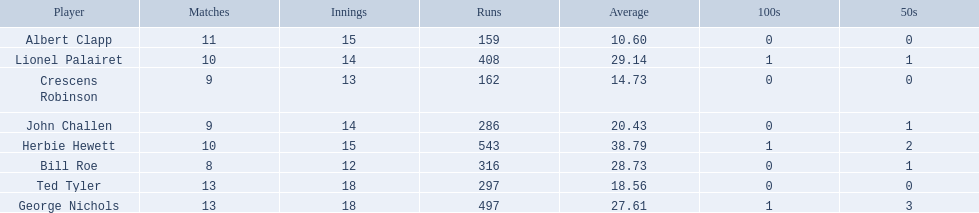Which players played in 10 or fewer matches? Herbie Hewett, Lionel Palairet, Bill Roe, John Challen, Crescens Robinson. Of these, which played in only 12 innings? Bill Roe. 